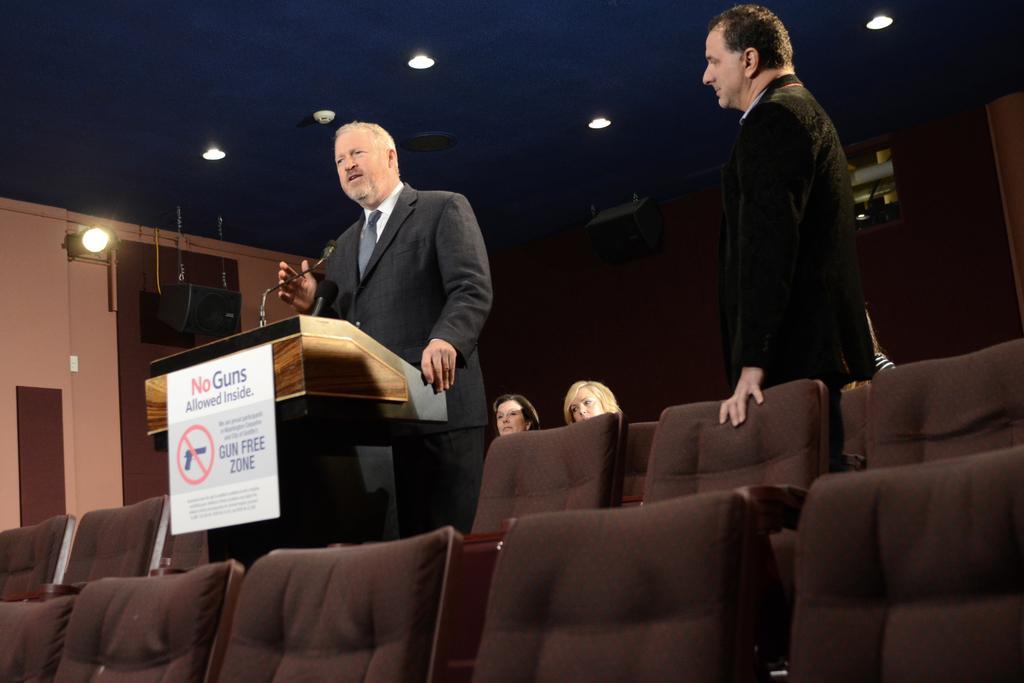Could you give a brief overview of what you see in this image? A man is standing behind the wooden stand And there is another person staring at him. There are two women sitting here, and also we have some chairs. 